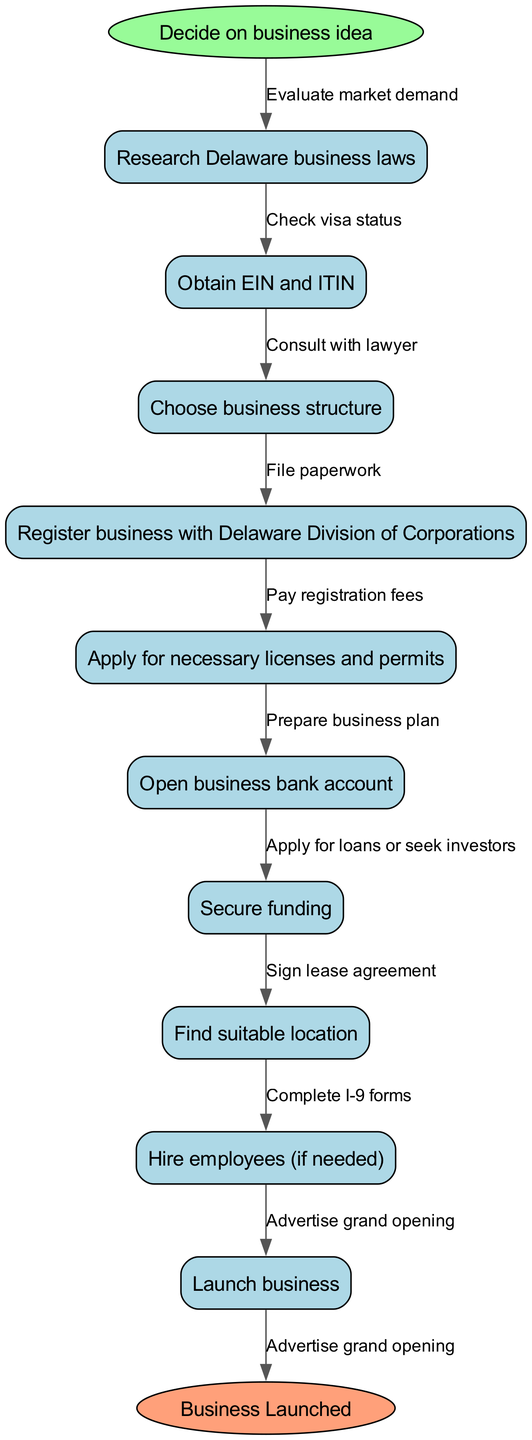What is the first step in the workflow? The first step is labeled as the start node, which is "Decide on business idea". This is the initial action required to begin the process of starting a business.
Answer: Decide on business idea How many nodes are there in the diagram? The diagram contains a total of 10 nodes: 1 start node, 9 business steps, and 1 end node. Counting each individual step and start/end gives us this total.
Answer: 10 What action follows "Choose business structure"? The action that follows is "Register business with Delaware Division of Corporations". This is determined by the direct connection from "Choose business structure" to the next node.
Answer: Register business with Delaware Division of Corporations What is the final step before launching the business? The final action before launching is "Advertise grand opening". This can be observed as the last edge leading to the end node, indicating the final preparation step.
Answer: Advertise grand opening Is "Secure funding" an earlier or later step than "Open business bank account"? "Secure funding" is an earlier step than "Open business bank account". In the workflow sequence, "Secure funding" occurs before the step that mentions opening a bank account, indicating it's done first.
Answer: Earlier What is the relationship between "Research Delaware business laws" and "Obtain EIN and ITIN"? "Research Delaware business laws" is the first node in the flowchart and directly leads to "Obtain EIN and ITIN", indicating it is a prerequisite action required before obtaining tax identification numbers.
Answer: Prerequisite Which business structure might you choose in this workflow? The diagram suggests "Choose business structure", indicating that you would select a legal structure for your business at this step.
Answer: Choose business structure How many edges are present in the flowchart? There are a total of 9 edges connecting the nodes, indicating the relationships and flow between each step in the process leading to the launch of the business.
Answer: 9 What step is required after securing funding? After securing funding, the next required step is "Find suitable location". This step is indicated by the flow from "Secure funding" to the subsequent node.
Answer: Find suitable location 